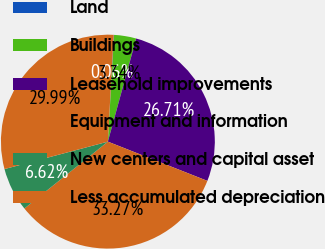Convert chart. <chart><loc_0><loc_0><loc_500><loc_500><pie_chart><fcel>Land<fcel>Buildings<fcel>Leasehold improvements<fcel>Equipment and information<fcel>New centers and capital asset<fcel>Less accumulated depreciation<nl><fcel>0.06%<fcel>3.34%<fcel>26.71%<fcel>33.27%<fcel>6.62%<fcel>29.99%<nl></chart> 